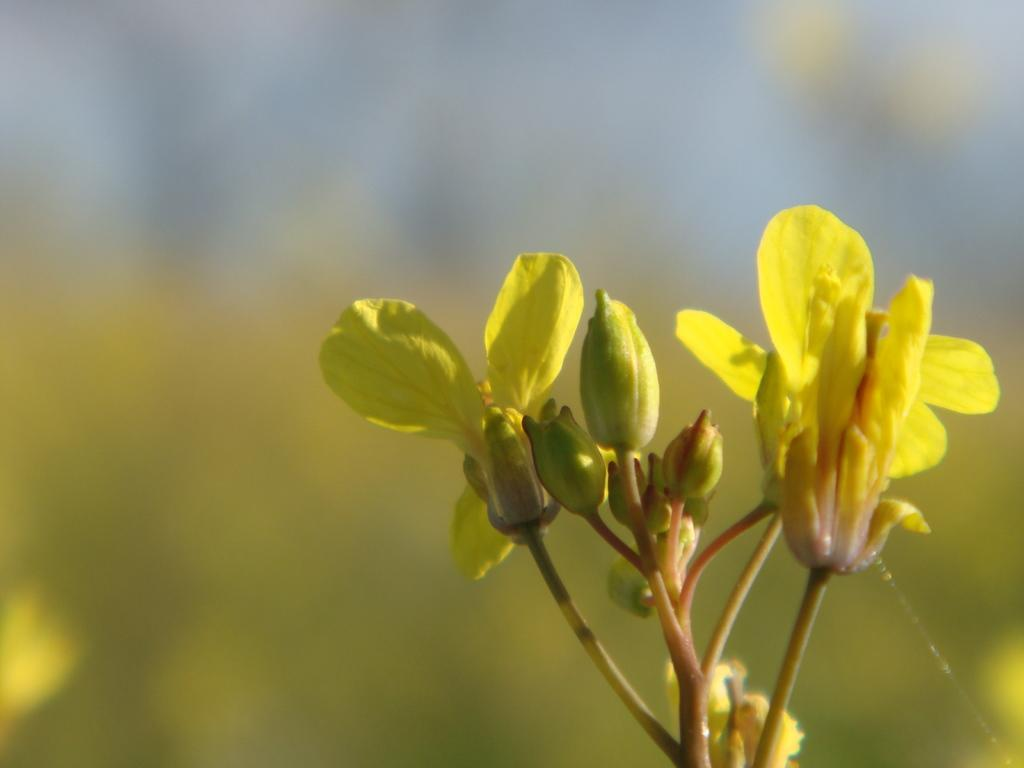What type of plant is visible in the image? There are flowers on a plant in the image. Where are the flowers located in relation to the rest of the image? The flowers are in the foreground area of the image. What type of balls are being used in the competition shown in the image? There is no competition or balls present in the image; it features a plant with flowers. How tall are the giants standing next to the flowers in the image? There are no giants present in the image; it features a plant with flowers. 